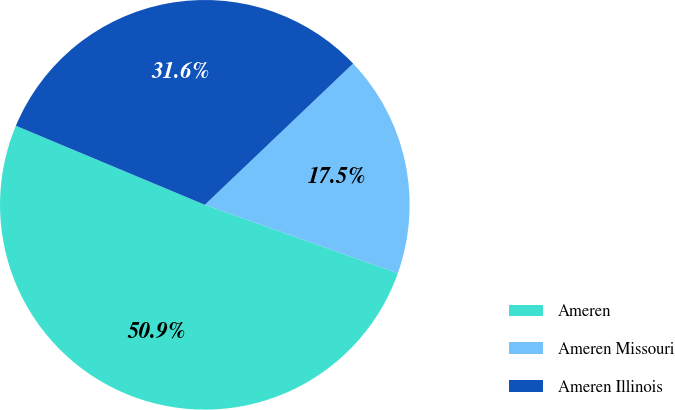<chart> <loc_0><loc_0><loc_500><loc_500><pie_chart><fcel>Ameren<fcel>Ameren Missouri<fcel>Ameren Illinois<nl><fcel>50.88%<fcel>17.54%<fcel>31.58%<nl></chart> 